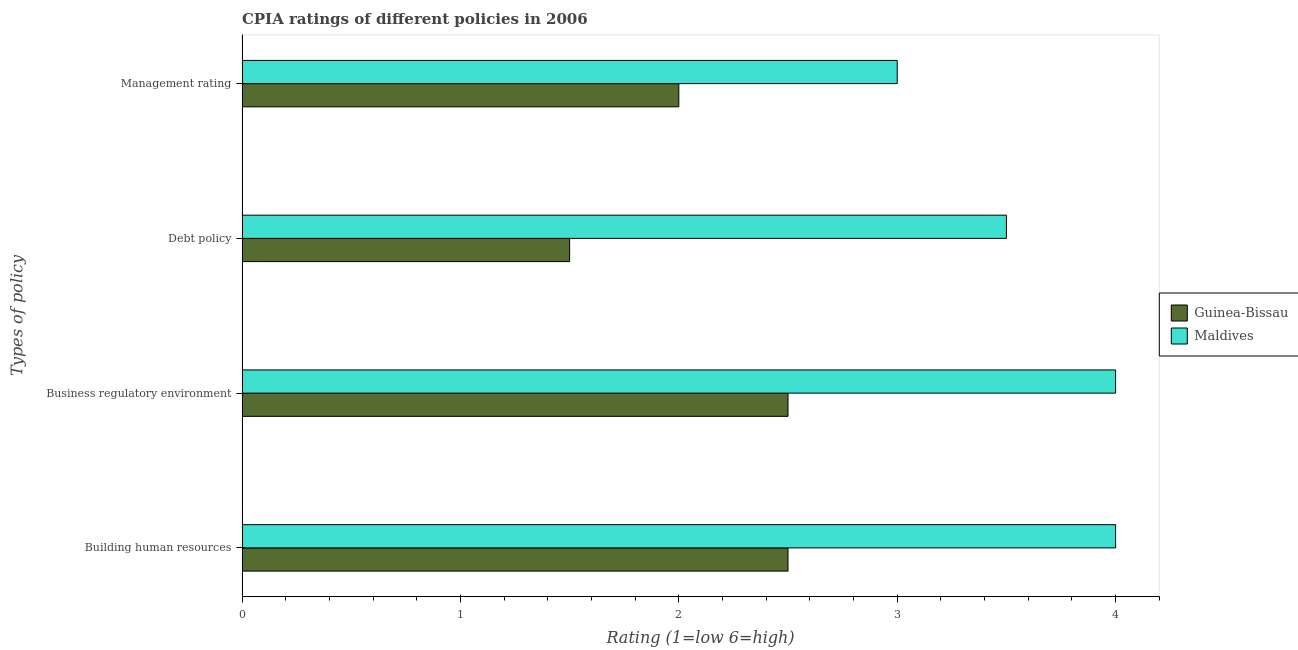How many different coloured bars are there?
Your answer should be very brief. 2. How many groups of bars are there?
Provide a succinct answer. 4. Are the number of bars per tick equal to the number of legend labels?
Keep it short and to the point. Yes. Are the number of bars on each tick of the Y-axis equal?
Provide a succinct answer. Yes. What is the label of the 2nd group of bars from the top?
Your answer should be compact. Debt policy. Across all countries, what is the minimum cpia rating of management?
Offer a terse response. 2. In which country was the cpia rating of business regulatory environment maximum?
Make the answer very short. Maldives. In which country was the cpia rating of debt policy minimum?
Your answer should be very brief. Guinea-Bissau. What is the difference between the cpia rating of business regulatory environment in Maldives and the cpia rating of building human resources in Guinea-Bissau?
Ensure brevity in your answer.  1.5. What is the difference between the cpia rating of management and cpia rating of debt policy in Guinea-Bissau?
Provide a short and direct response. 0.5. In how many countries, is the cpia rating of business regulatory environment greater than 0.6000000000000001 ?
Provide a succinct answer. 2. What is the ratio of the cpia rating of debt policy in Maldives to that in Guinea-Bissau?
Your answer should be very brief. 2.33. What is the difference between the highest and the lowest cpia rating of management?
Keep it short and to the point. 1. Is the sum of the cpia rating of debt policy in Guinea-Bissau and Maldives greater than the maximum cpia rating of business regulatory environment across all countries?
Keep it short and to the point. Yes. Is it the case that in every country, the sum of the cpia rating of debt policy and cpia rating of business regulatory environment is greater than the sum of cpia rating of building human resources and cpia rating of management?
Your answer should be compact. No. What does the 1st bar from the top in Debt policy represents?
Your response must be concise. Maldives. What does the 2nd bar from the bottom in Building human resources represents?
Give a very brief answer. Maldives. Is it the case that in every country, the sum of the cpia rating of building human resources and cpia rating of business regulatory environment is greater than the cpia rating of debt policy?
Keep it short and to the point. Yes. What is the difference between two consecutive major ticks on the X-axis?
Your answer should be very brief. 1. Are the values on the major ticks of X-axis written in scientific E-notation?
Offer a very short reply. No. Does the graph contain grids?
Give a very brief answer. No. How many legend labels are there?
Ensure brevity in your answer.  2. How are the legend labels stacked?
Offer a very short reply. Vertical. What is the title of the graph?
Your answer should be very brief. CPIA ratings of different policies in 2006. Does "OECD members" appear as one of the legend labels in the graph?
Your answer should be very brief. No. What is the label or title of the X-axis?
Keep it short and to the point. Rating (1=low 6=high). What is the label or title of the Y-axis?
Provide a short and direct response. Types of policy. What is the Rating (1=low 6=high) of Maldives in Building human resources?
Provide a succinct answer. 4. What is the Rating (1=low 6=high) of Maldives in Business regulatory environment?
Provide a succinct answer. 4. What is the Rating (1=low 6=high) of Guinea-Bissau in Management rating?
Provide a short and direct response. 2. What is the Rating (1=low 6=high) in Maldives in Management rating?
Provide a short and direct response. 3. Across all Types of policy, what is the maximum Rating (1=low 6=high) in Maldives?
Give a very brief answer. 4. Across all Types of policy, what is the minimum Rating (1=low 6=high) of Guinea-Bissau?
Provide a succinct answer. 1.5. What is the total Rating (1=low 6=high) in Guinea-Bissau in the graph?
Your response must be concise. 8.5. What is the total Rating (1=low 6=high) in Maldives in the graph?
Your answer should be compact. 14.5. What is the difference between the Rating (1=low 6=high) in Maldives in Building human resources and that in Debt policy?
Provide a short and direct response. 0.5. What is the difference between the Rating (1=low 6=high) of Maldives in Building human resources and that in Management rating?
Keep it short and to the point. 1. What is the difference between the Rating (1=low 6=high) in Guinea-Bissau in Business regulatory environment and that in Debt policy?
Your response must be concise. 1. What is the difference between the Rating (1=low 6=high) in Guinea-Bissau in Business regulatory environment and that in Management rating?
Ensure brevity in your answer.  0.5. What is the difference between the Rating (1=low 6=high) of Guinea-Bissau in Debt policy and that in Management rating?
Your answer should be compact. -0.5. What is the difference between the Rating (1=low 6=high) of Maldives in Debt policy and that in Management rating?
Provide a succinct answer. 0.5. What is the difference between the Rating (1=low 6=high) in Guinea-Bissau in Building human resources and the Rating (1=low 6=high) in Maldives in Business regulatory environment?
Give a very brief answer. -1.5. What is the difference between the Rating (1=low 6=high) of Guinea-Bissau in Business regulatory environment and the Rating (1=low 6=high) of Maldives in Debt policy?
Give a very brief answer. -1. What is the difference between the Rating (1=low 6=high) in Guinea-Bissau in Business regulatory environment and the Rating (1=low 6=high) in Maldives in Management rating?
Offer a terse response. -0.5. What is the average Rating (1=low 6=high) of Guinea-Bissau per Types of policy?
Make the answer very short. 2.12. What is the average Rating (1=low 6=high) in Maldives per Types of policy?
Make the answer very short. 3.62. What is the difference between the Rating (1=low 6=high) of Guinea-Bissau and Rating (1=low 6=high) of Maldives in Building human resources?
Your answer should be very brief. -1.5. What is the difference between the Rating (1=low 6=high) of Guinea-Bissau and Rating (1=low 6=high) of Maldives in Business regulatory environment?
Keep it short and to the point. -1.5. What is the difference between the Rating (1=low 6=high) in Guinea-Bissau and Rating (1=low 6=high) in Maldives in Debt policy?
Give a very brief answer. -2. What is the difference between the Rating (1=low 6=high) in Guinea-Bissau and Rating (1=low 6=high) in Maldives in Management rating?
Your answer should be very brief. -1. What is the ratio of the Rating (1=low 6=high) of Maldives in Building human resources to that in Business regulatory environment?
Provide a succinct answer. 1. What is the ratio of the Rating (1=low 6=high) in Guinea-Bissau in Building human resources to that in Debt policy?
Your response must be concise. 1.67. What is the ratio of the Rating (1=low 6=high) in Guinea-Bissau in Building human resources to that in Management rating?
Give a very brief answer. 1.25. What is the ratio of the Rating (1=low 6=high) in Maldives in Building human resources to that in Management rating?
Ensure brevity in your answer.  1.33. What is the ratio of the Rating (1=low 6=high) of Guinea-Bissau in Business regulatory environment to that in Debt policy?
Your answer should be compact. 1.67. What is the ratio of the Rating (1=low 6=high) of Maldives in Business regulatory environment to that in Debt policy?
Your answer should be compact. 1.14. What is the ratio of the Rating (1=low 6=high) of Guinea-Bissau in Business regulatory environment to that in Management rating?
Ensure brevity in your answer.  1.25. What is the ratio of the Rating (1=low 6=high) in Guinea-Bissau in Debt policy to that in Management rating?
Your answer should be very brief. 0.75. What is the ratio of the Rating (1=low 6=high) of Maldives in Debt policy to that in Management rating?
Provide a succinct answer. 1.17. What is the difference between the highest and the second highest Rating (1=low 6=high) in Guinea-Bissau?
Your response must be concise. 0. What is the difference between the highest and the second highest Rating (1=low 6=high) of Maldives?
Your response must be concise. 0. What is the difference between the highest and the lowest Rating (1=low 6=high) in Maldives?
Offer a very short reply. 1. 